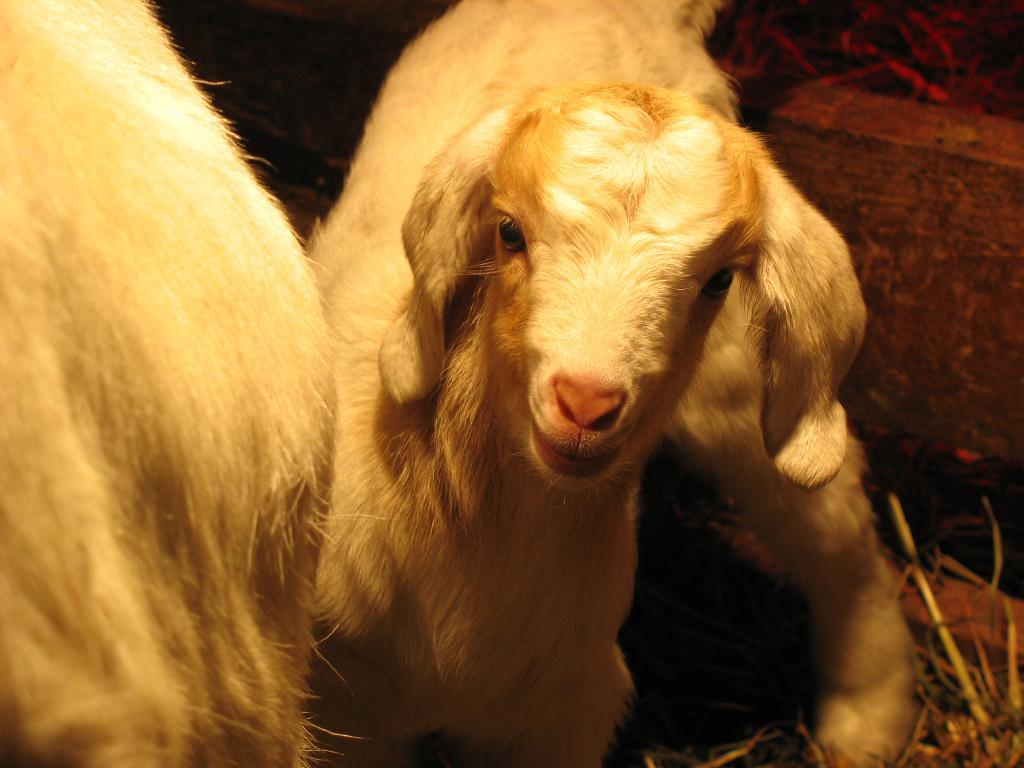What type of animal is in the image? There is a white-colored goat in the image. What is the goat standing on in the image? There is grass visible in the image, which the goat is likely standing on. What color is the other object in the image? There is a white-colored object in the image. How does the goat's brother react to its sneeze in the image? There is no indication of a brother or a sneeze in the image, as it only features a white-colored goat and grass. 